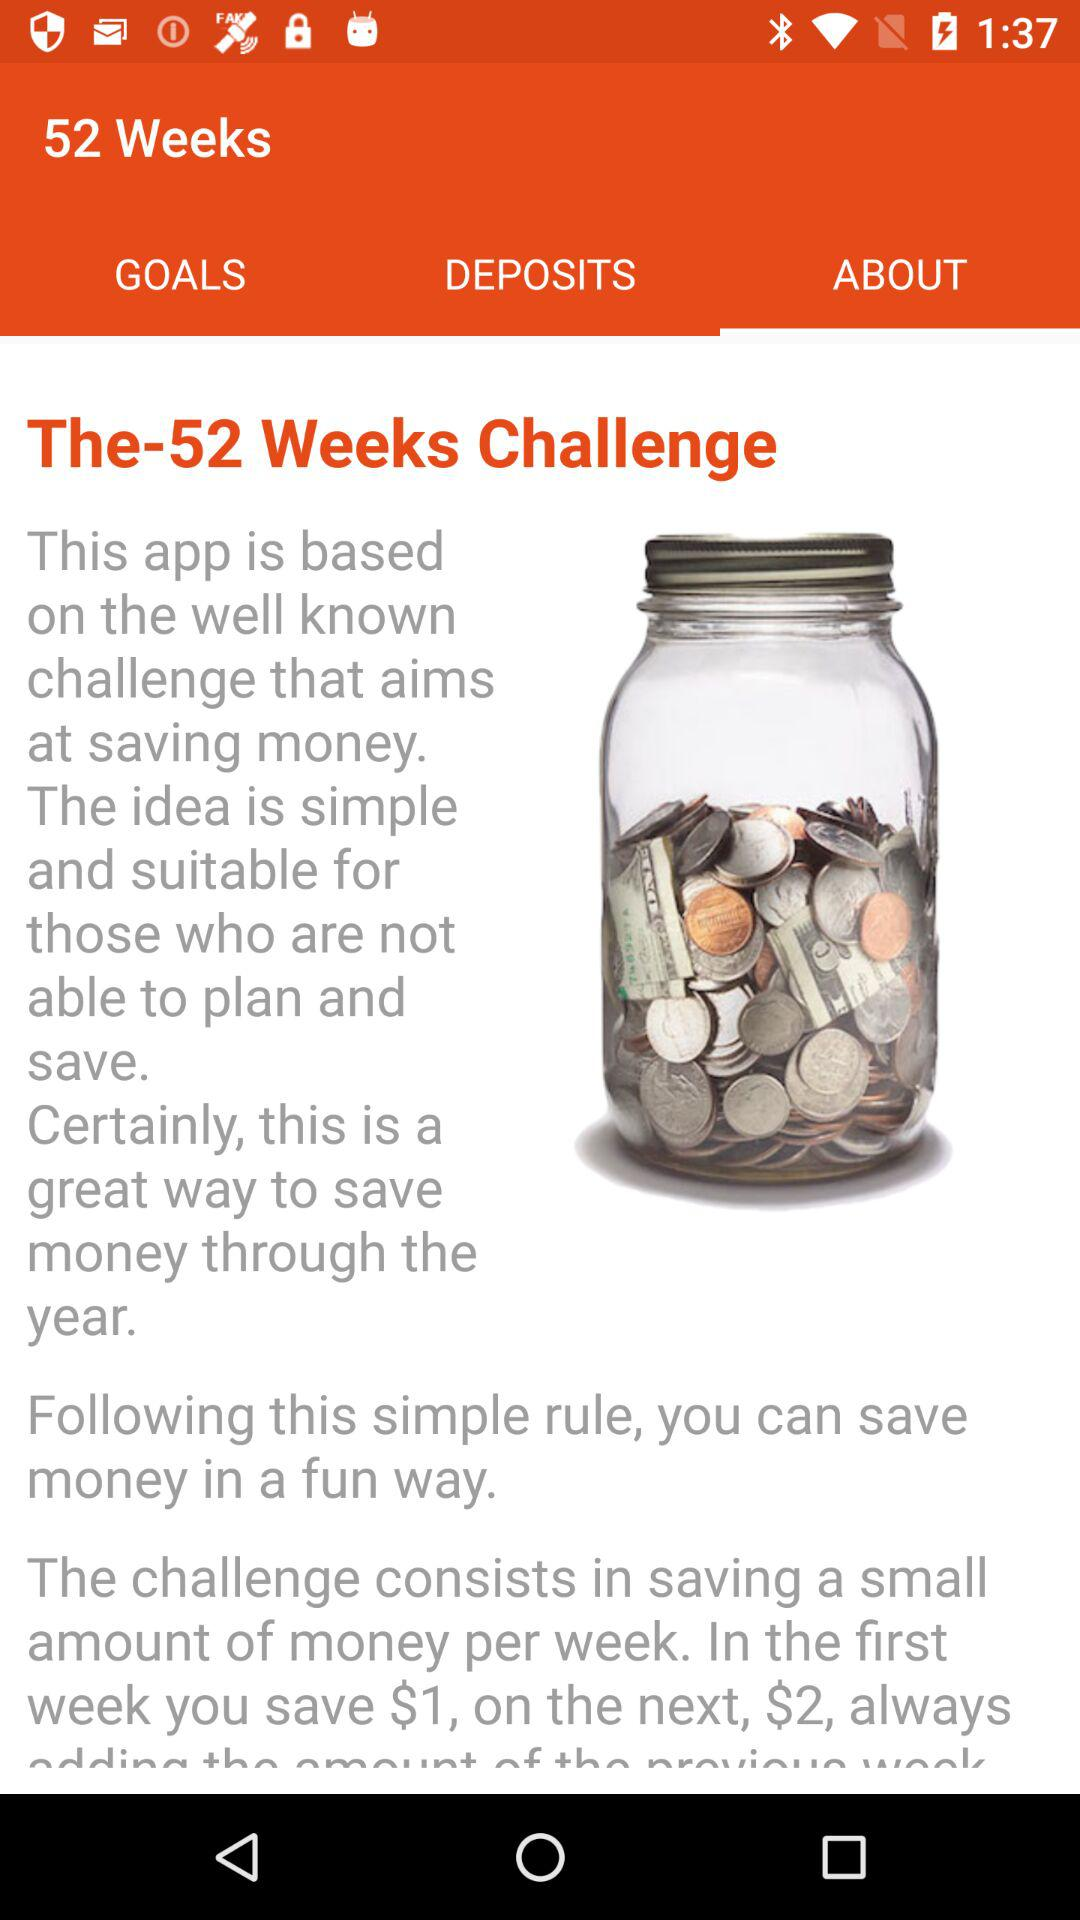How many weeks of challenges are there? There are 52 weeks of challenges. 